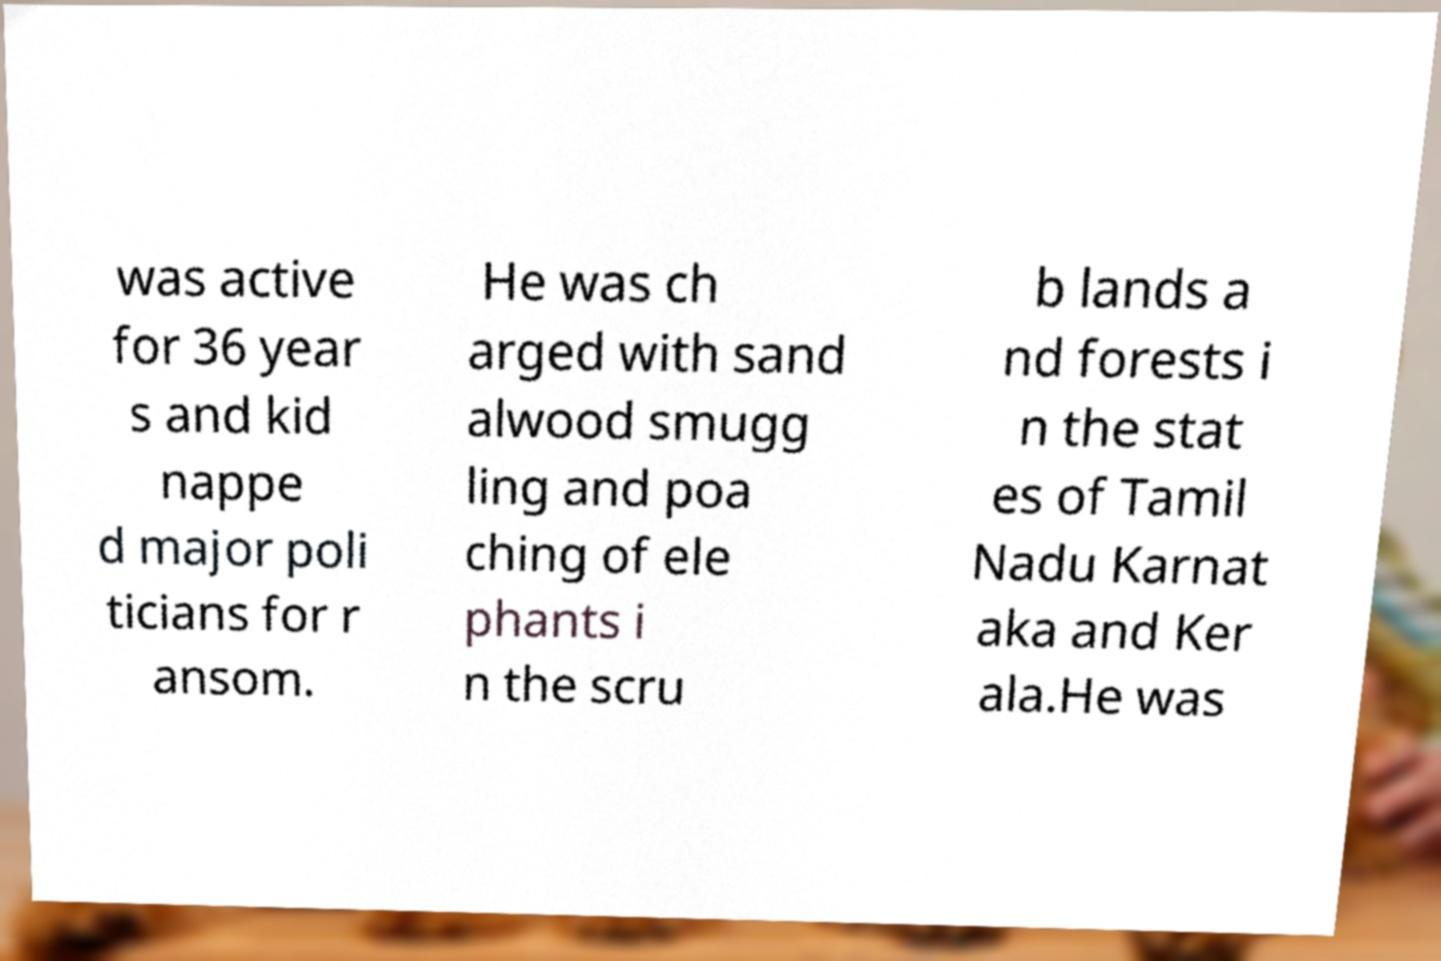Can you read and provide the text displayed in the image?This photo seems to have some interesting text. Can you extract and type it out for me? was active for 36 year s and kid nappe d major poli ticians for r ansom. He was ch arged with sand alwood smugg ling and poa ching of ele phants i n the scru b lands a nd forests i n the stat es of Tamil Nadu Karnat aka and Ker ala.He was 